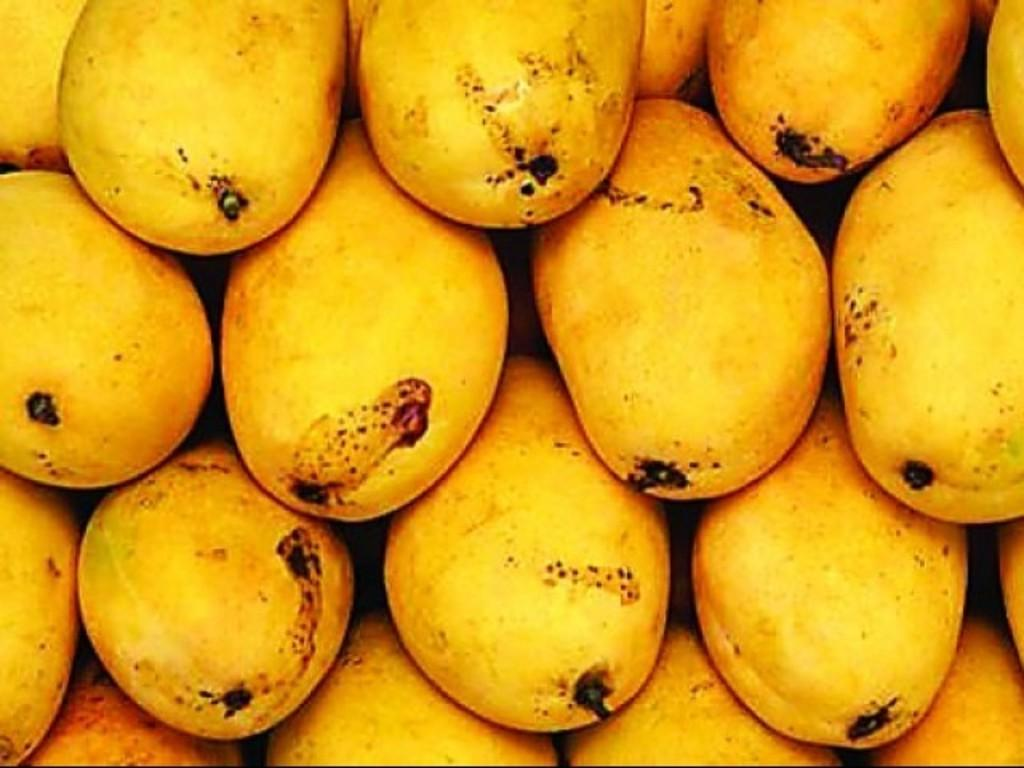What type of fruit is present in the image? There are mangoes in the image. What color are the mangoes? The mangoes are yellow in color. What type of slope can be seen in the image? There is no slope present in the image; it features mangoes. What type of clouds are visible in the image? There are no clouds visible in the image; it features mangoes. 